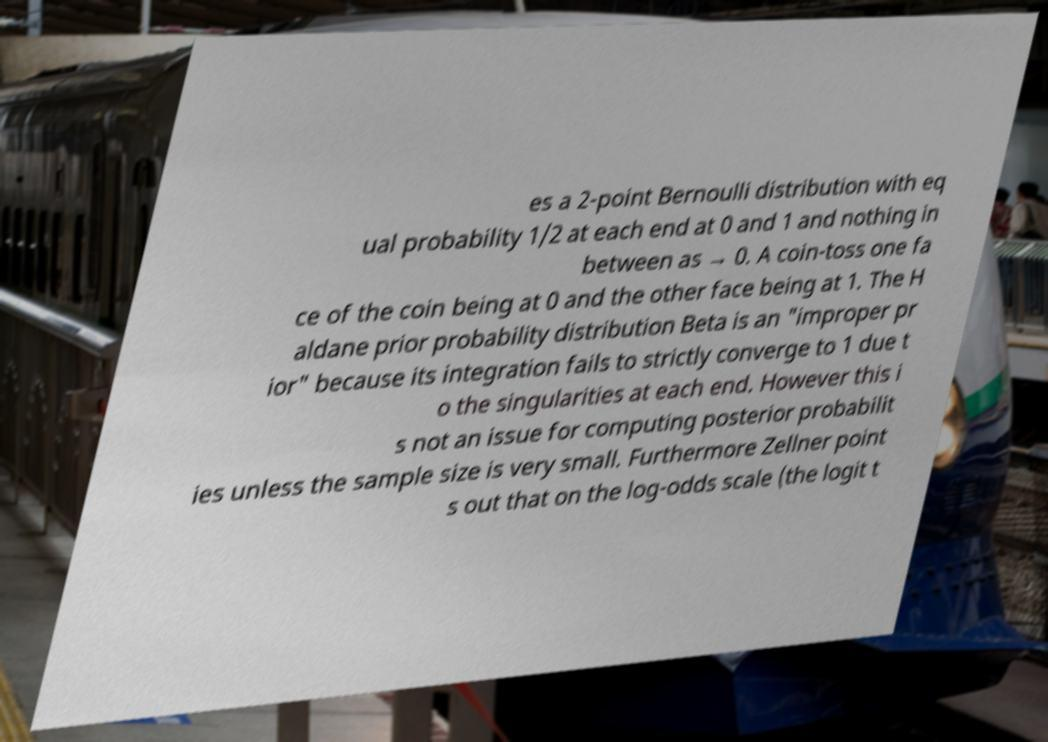There's text embedded in this image that I need extracted. Can you transcribe it verbatim? es a 2-point Bernoulli distribution with eq ual probability 1/2 at each end at 0 and 1 and nothing in between as → 0. A coin-toss one fa ce of the coin being at 0 and the other face being at 1. The H aldane prior probability distribution Beta is an "improper pr ior" because its integration fails to strictly converge to 1 due t o the singularities at each end. However this i s not an issue for computing posterior probabilit ies unless the sample size is very small. Furthermore Zellner point s out that on the log-odds scale (the logit t 